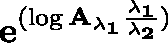Convert formula to latex. <formula><loc_0><loc_0><loc_500><loc_500>e ^ { ( \log \mathbf { { A _ { \lambda _ { 1 } } } } \frac { \lambda _ { 1 } } { \lambda _ { 2 } } ) }</formula> 